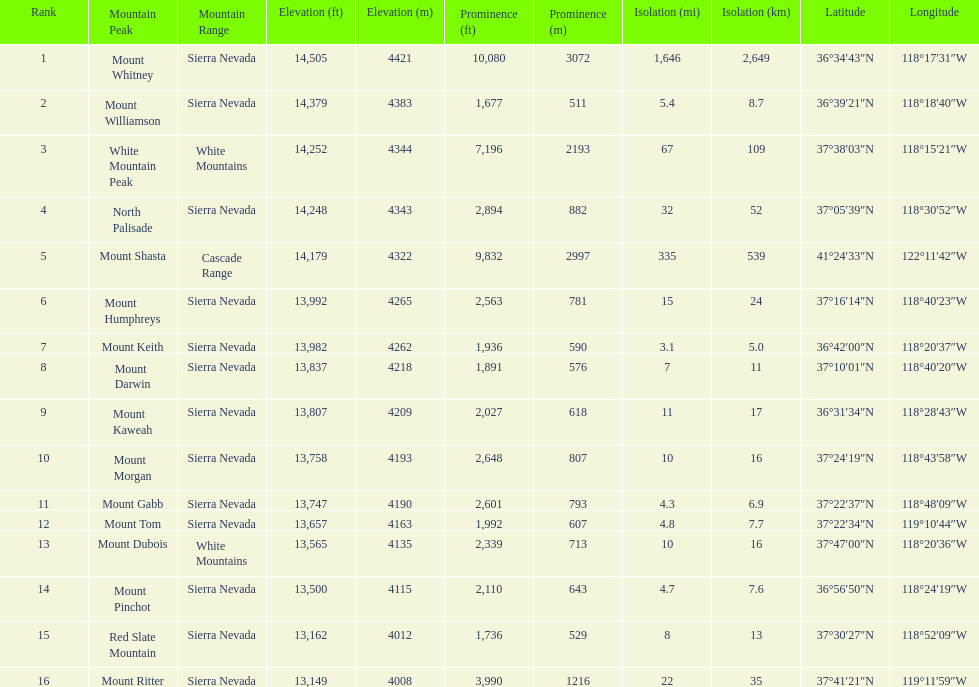Is the peak of mount keith above or below the peak of north palisade? Below. 